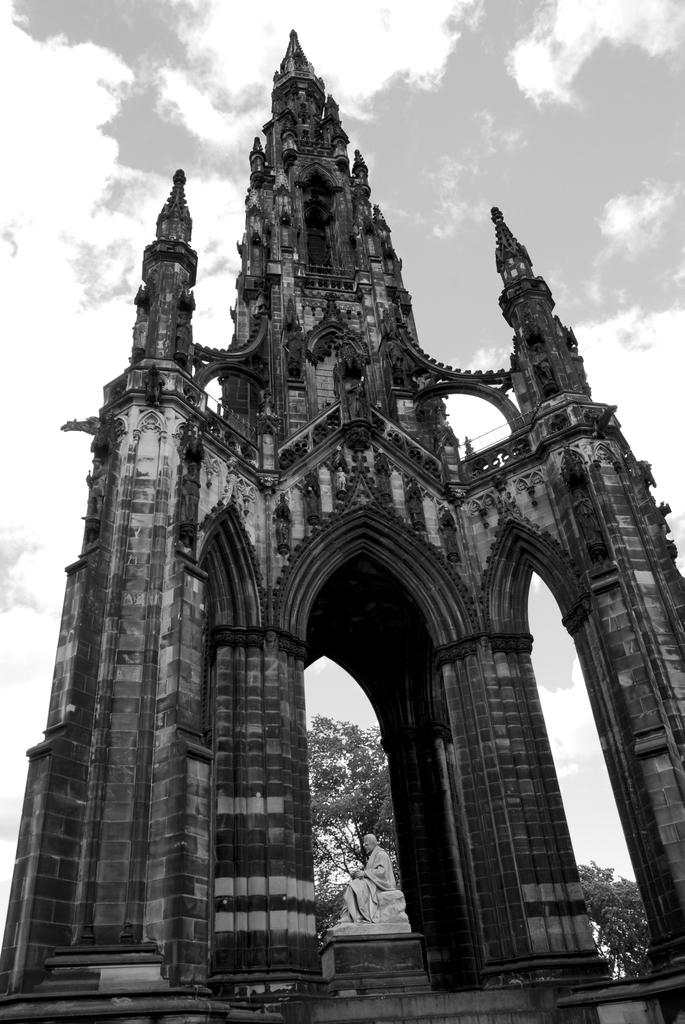What type of structure is visible in the image? There is a building in the image. Can you describe the appearance of the building? The building appears to be an old construction. What other objects or features can be seen in the image? There is a white color statue in the image. What can be seen in the background of the image? There are trees and the sky visible in the background of the image. What is the condition of the sky in the image? Clouds are present in the sky. How does the building show respect for the deceased in the image? There is no indication in the image that the building is related to the deceased or shows respect for them. What type of weather, such as sleet, is present in the image? There is no mention of weather in the image. 